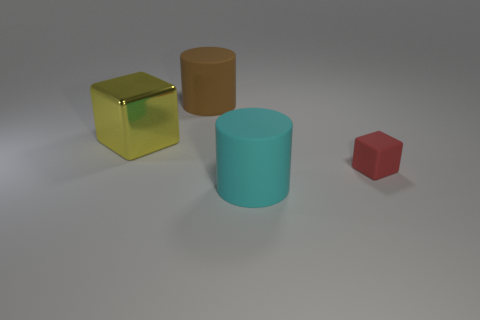The cyan matte object that is left of the block to the right of the large shiny cube is what shape?
Make the answer very short. Cylinder. How big is the thing that is right of the rubber cylinder that is in front of the big matte cylinder that is behind the large cyan thing?
Ensure brevity in your answer.  Small. There is another matte object that is the same shape as the cyan thing; what color is it?
Your response must be concise. Brown. Do the cyan thing and the red matte object have the same size?
Provide a succinct answer. No. There is a cube that is in front of the large cube; what is it made of?
Give a very brief answer. Rubber. What number of other objects are there of the same shape as the big metal thing?
Make the answer very short. 1. Are there an equal number of small red things and small brown matte cylinders?
Give a very brief answer. No. Is the shape of the large brown matte object the same as the cyan matte thing?
Make the answer very short. Yes. There is a small matte object; are there any brown objects to the right of it?
Your response must be concise. No. What number of objects are either yellow metal blocks or small purple spheres?
Offer a very short reply. 1. 